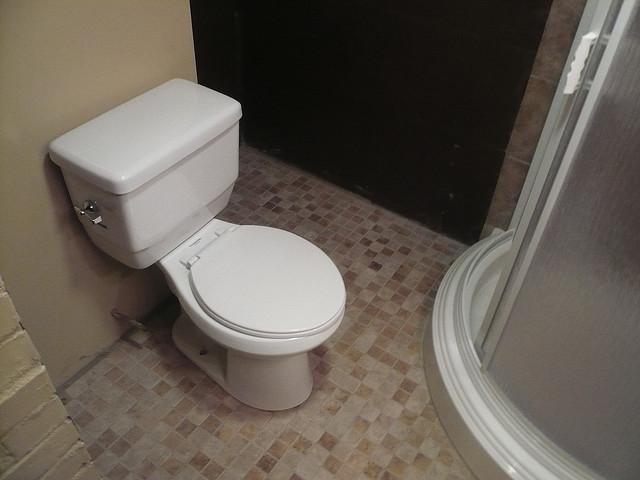Is the toilet broken?
Concise answer only. No. Is the toilet seat up or down?
Be succinct. Down. Where is the flush handle?
Quick response, please. Left side. Is the bathroom clean?
Be succinct. Yes. What was this photo taken through?
Write a very short answer. Lens. Is the toilet lid up or down?
Write a very short answer. Down. Would you feel comfortable using this toilet?
Keep it brief. Yes. What room is the picture taken in?
Be succinct. Bathroom. Is the lid down?
Answer briefly. Yes. 